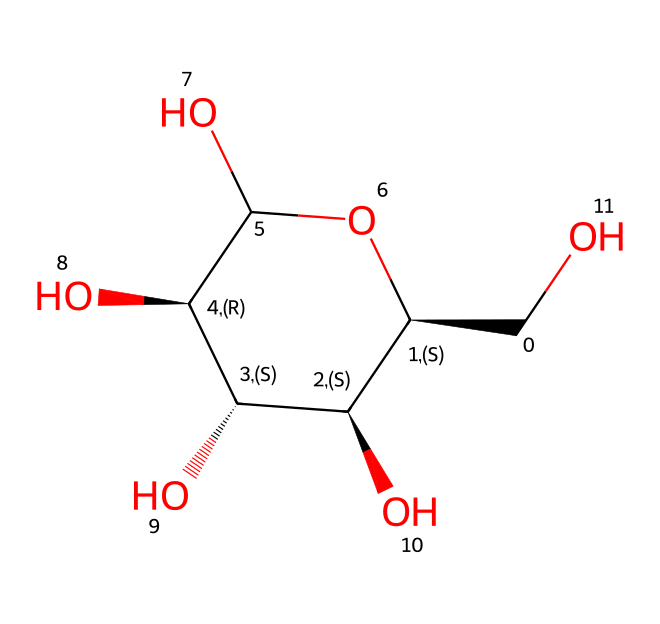How many carbon atoms are in the structure? By analyzing the SMILES representation, we count the carbon (C) symbols, which indicate carbon atoms. In this case, there are six carbon atoms present.
Answer: six What is the functional group present in this chemical? The structure includes hydroxyl groups (–OH), which are characterized by an oxygen atom bonded to a hydrogen atom. This indicates that there are multiple hydroxyl groups present in the molecule.
Answer: hydroxyl How many hydroxyl groups are present in the molecule? Looking closely at the chemical structure, we can identify four hydroxyl groups. Each group is attached to a carbon atom, contributing to the molecule's hydrophilic properties.
Answer: four What type of polymer is represented by this structure? The structure represents cellulose, a polysaccharide made up of glucose units linked together. Cellulose is a natural polymer commonly found in cotton fibers.
Answer: cellulose What is the main element that constitutes the backbone of this chemical structure? The backbone of the structure is primarily made up of carbon atoms, which form the main framework of the polymer. Each carbon is connected to hydroxyl groups and creates a stable structure.
Answer: carbon How does the presence of hydroxyl groups affect cotton fibers? The presence of hydroxyl groups contributes to the hydrophilic nature of cotton fibers, allowing them to absorb moisture easily, enhancing breathability and comfort in clothing.
Answer: absorb moisture 